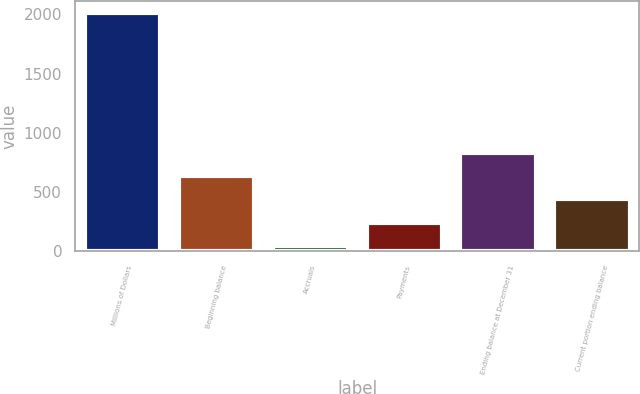Convert chart to OTSL. <chart><loc_0><loc_0><loc_500><loc_500><bar_chart><fcel>Millions of Dollars<fcel>Beginning balance<fcel>Accruals<fcel>Payments<fcel>Ending balance at December 31<fcel>Current portion ending balance<nl><fcel>2008<fcel>634.6<fcel>46<fcel>242.2<fcel>830.8<fcel>438.4<nl></chart> 